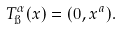Convert formula to latex. <formula><loc_0><loc_0><loc_500><loc_500>T _ { \i } ^ { \alpha } ( x ) = ( 0 , x ^ { a } ) .</formula> 